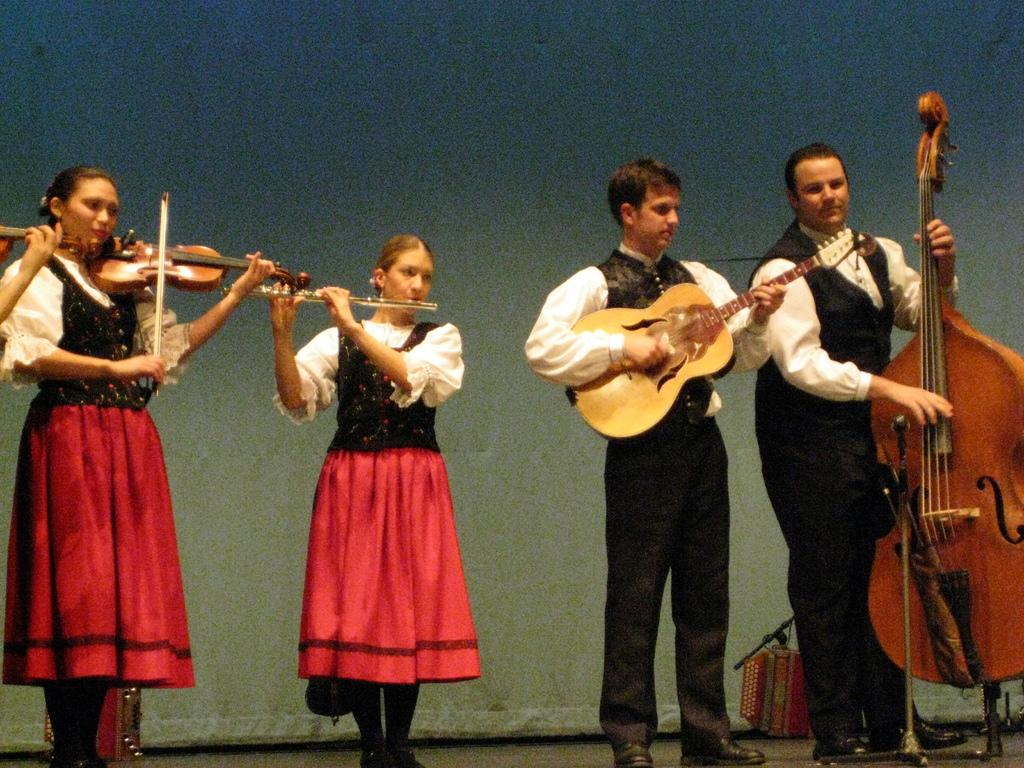How many people are in the image? There are four people in the image. Can you describe the gender of the people in the image? Two of the people are women, and two are men. What are the people in the image doing? All four people are playing musical instruments. What type of meat is being cooked by the people in the image? There is no meat or cooking activity present in the image; the people are playing musical instruments. 